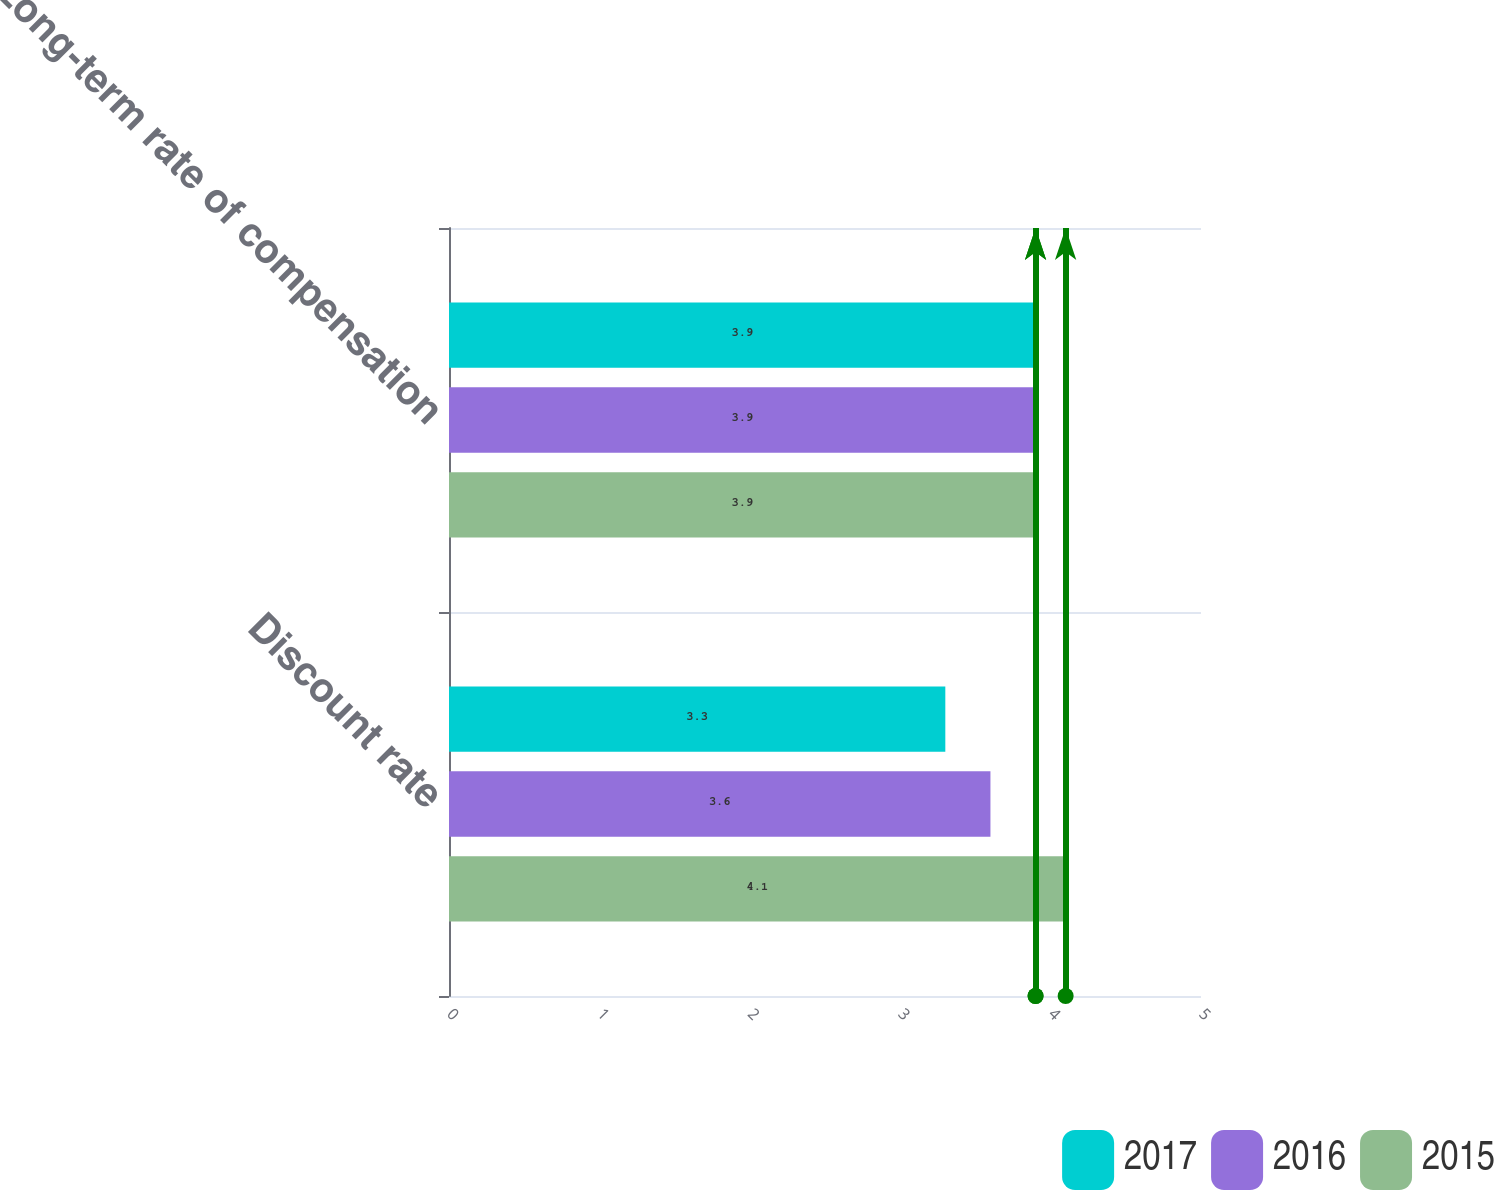Convert chart to OTSL. <chart><loc_0><loc_0><loc_500><loc_500><stacked_bar_chart><ecel><fcel>Discount rate<fcel>Long-term rate of compensation<nl><fcel>2017<fcel>3.3<fcel>3.9<nl><fcel>2016<fcel>3.6<fcel>3.9<nl><fcel>2015<fcel>4.1<fcel>3.9<nl></chart> 